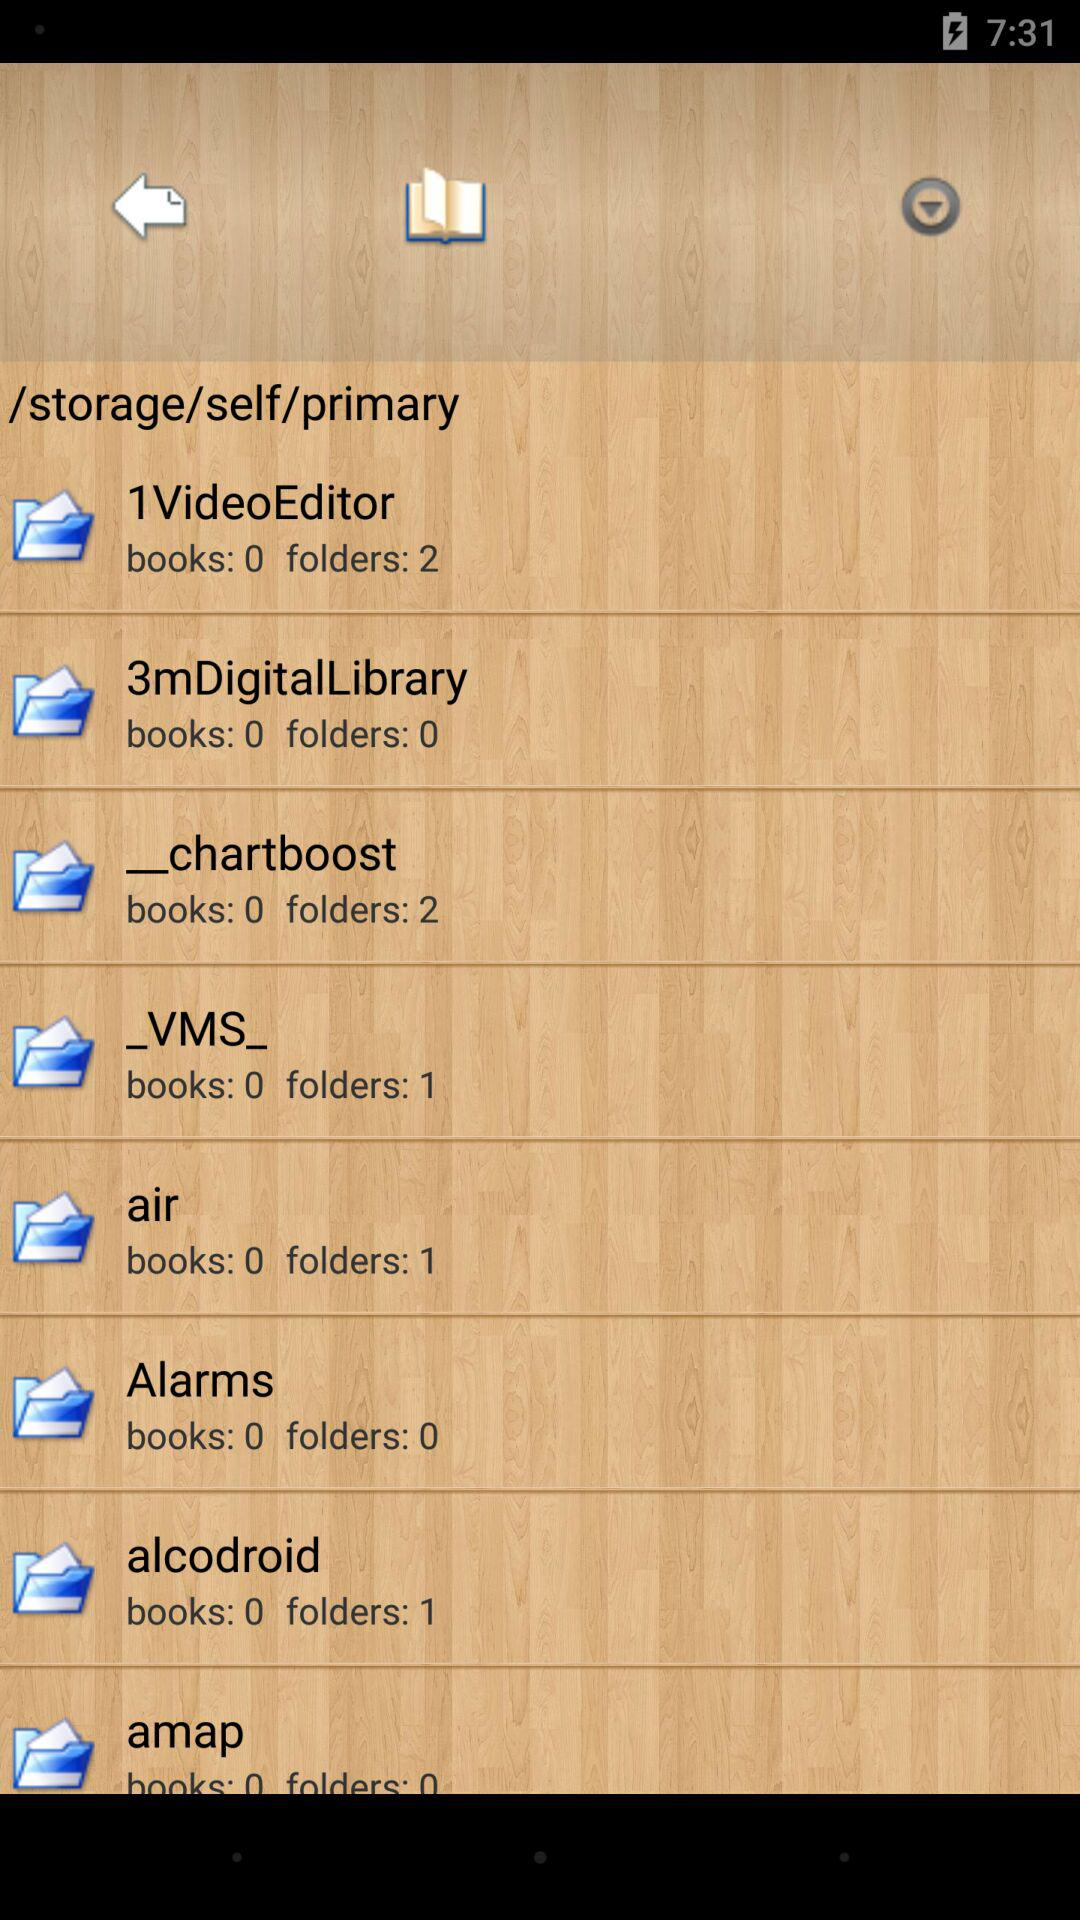What's the count of books in "air"? The count of books is 0. 